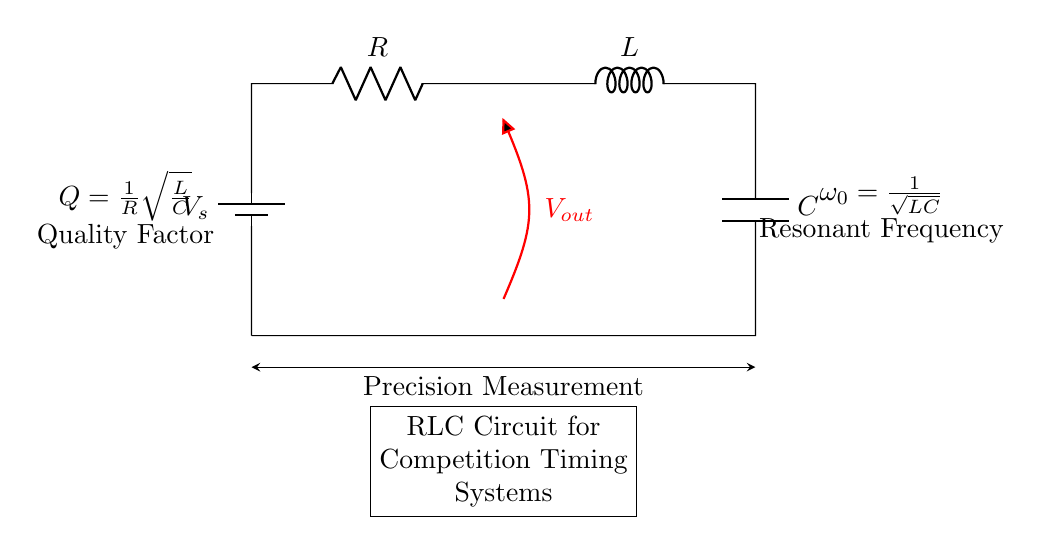What are the components of this circuit? The components in the circuit are a battery, resistor, inductor, and capacitor. These are labeled directly in the diagram as V_s, R, L, and C, respectively.
Answer: battery, resistor, inductor, capacitor What does V_out represent in the circuit? V_out represents the output voltage taken across the resistor. In the diagram, it is shown as a voltage measurement connecting to the resistor at point (4,4) and extending downwards.
Answer: output voltage What is the resonant frequency formula indicated in the circuit? The resonant frequency formula is provided in the circuit diagram as ω₀ = 1/√(LC). This indicates how the resonance frequency depends on the values of the inductor (L) and capacitor (C).
Answer: 1/√(LC) What does the quality factor Q represent in this RLC circuit? The quality factor Q in the RLC circuit is given by the formula Q = (1/R)√(L/C). It is a dimensionless parameter that describes the selectivity of the circuit, indicating how underdamped the oscillator is.
Answer: 1/R√(L/C) How does increasing the resistance R affect the quality factor Q? Increasing the resistance R will decrease the quality factor Q, because Q is inversely proportional to R. As R increases, the damping increases, which typically leads to a broader resonance peak and lower selectivity.
Answer: decreases What happens to the output voltage V_out at resonance? At resonance, the impedance of the circuit is minimized, and the output voltage V_out reaches its maximum value because energy oscillates between the inductor and capacitor with minimal resistive loss.
Answer: maximum 